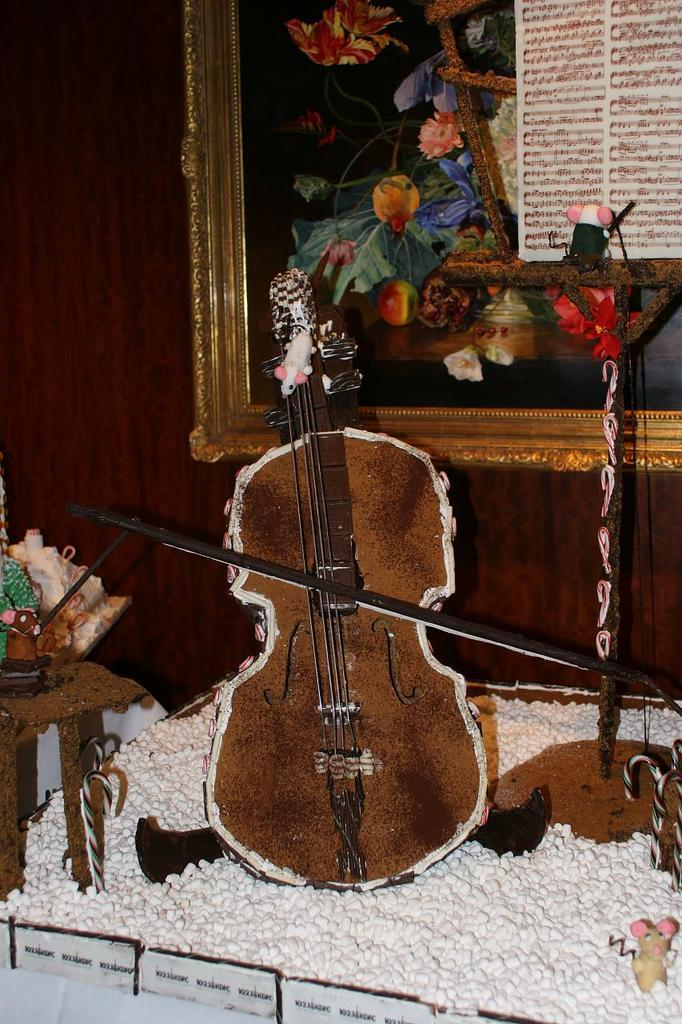What object in the image is typically used for displaying photographs? There is a photo frame in the image. What musical instrument can be seen in the image? There is a guitar in the image. Is there a volcano erupting in the background of the image? There is no mention of a volcano or any eruption in the provided facts, so we cannot determine if there is a volcano in the image. 